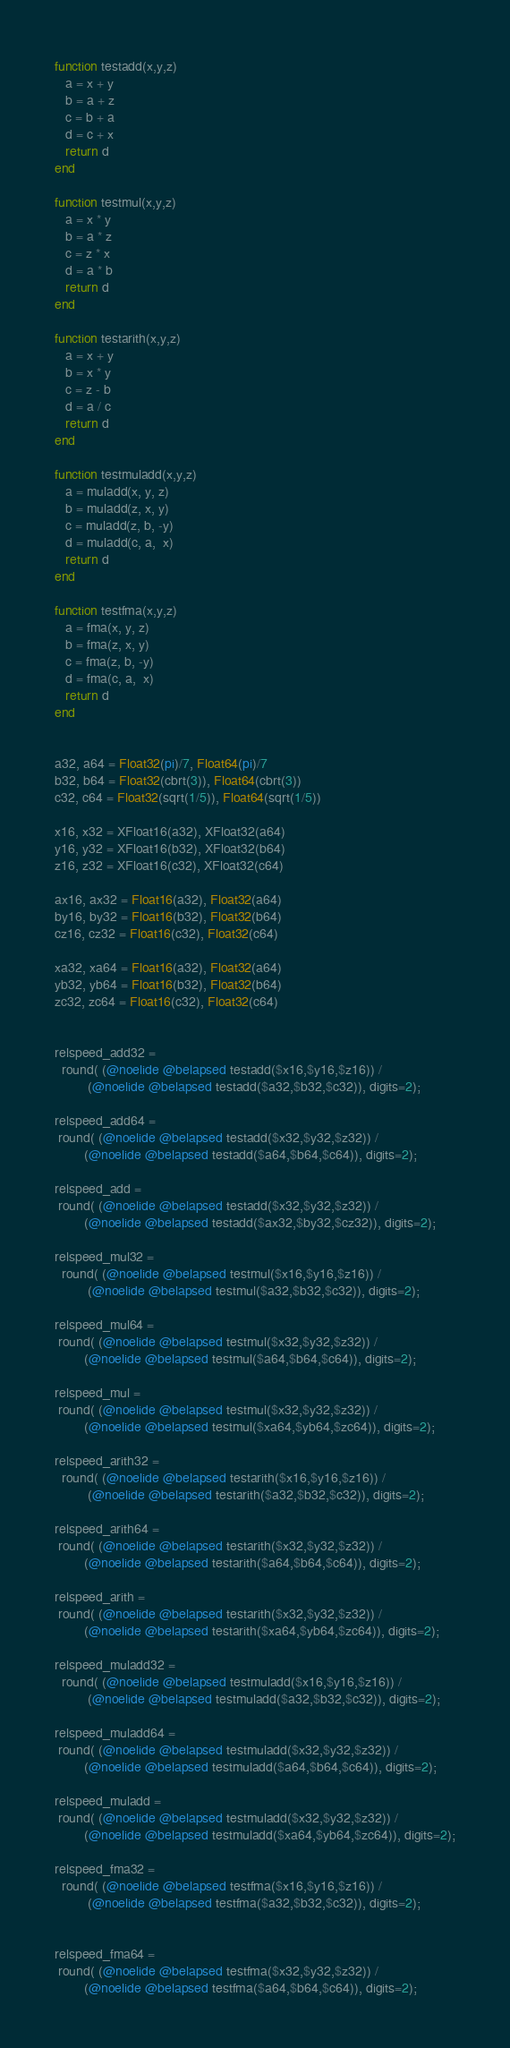<code> <loc_0><loc_0><loc_500><loc_500><_Julia_>
function testadd(x,y,z)
   a = x + y
   b = a + z
   c = b + a
   d = c + x
   return d
end

function testmul(x,y,z)
   a = x * y
   b = a * z
   c = z * x
   d = a * b
   return d
end

function testarith(x,y,z)
   a = x + y
   b = x * y
   c = z - b
   d = a / c
   return d
end

function testmuladd(x,y,z)
   a = muladd(x, y, z)
   b = muladd(z, x, y)
   c = muladd(z, b, -y)
   d = muladd(c, a,  x)
   return d
end

function testfma(x,y,z)
   a = fma(x, y, z)
   b = fma(z, x, y)
   c = fma(z, b, -y)
   d = fma(c, a,  x)
   return d
end


a32, a64 = Float32(pi)/7, Float64(pi)/7
b32, b64 = Float32(cbrt(3)), Float64(cbrt(3))
c32, c64 = Float32(sqrt(1/5)), Float64(sqrt(1/5))

x16, x32 = XFloat16(a32), XFloat32(a64)
y16, y32 = XFloat16(b32), XFloat32(b64)
z16, z32 = XFloat16(c32), XFloat32(c64)

ax16, ax32 = Float16(a32), Float32(a64)
by16, by32 = Float16(b32), Float32(b64)
cz16, cz32 = Float16(c32), Float32(c64)

xa32, xa64 = Float16(a32), Float32(a64)
yb32, yb64 = Float16(b32), Float32(b64)
zc32, zc64 = Float16(c32), Float32(c64)


relspeed_add32 =
  round( (@noelide @belapsed testadd($x16,$y16,$z16)) /
         (@noelide @belapsed testadd($a32,$b32,$c32)), digits=2);

relspeed_add64 =
 round( (@noelide @belapsed testadd($x32,$y32,$z32)) /
        (@noelide @belapsed testadd($a64,$b64,$c64)), digits=2);

relspeed_add =
 round( (@noelide @belapsed testadd($x32,$y32,$z32)) /
        (@noelide @belapsed testadd($ax32,$by32,$cz32)), digits=2);

relspeed_mul32 =
  round( (@noelide @belapsed testmul($x16,$y16,$z16)) /
         (@noelide @belapsed testmul($a32,$b32,$c32)), digits=2);

relspeed_mul64 =
 round( (@noelide @belapsed testmul($x32,$y32,$z32)) /
        (@noelide @belapsed testmul($a64,$b64,$c64)), digits=2);

relspeed_mul =
 round( (@noelide @belapsed testmul($x32,$y32,$z32)) /
        (@noelide @belapsed testmul($xa64,$yb64,$zc64)), digits=2);

relspeed_arith32 =
  round( (@noelide @belapsed testarith($x16,$y16,$z16)) /
         (@noelide @belapsed testarith($a32,$b32,$c32)), digits=2);

relspeed_arith64 =
 round( (@noelide @belapsed testarith($x32,$y32,$z32)) /
        (@noelide @belapsed testarith($a64,$b64,$c64)), digits=2);

relspeed_arith =
 round( (@noelide @belapsed testarith($x32,$y32,$z32)) /
        (@noelide @belapsed testarith($xa64,$yb64,$zc64)), digits=2);

relspeed_muladd32 =
  round( (@noelide @belapsed testmuladd($x16,$y16,$z16)) /
         (@noelide @belapsed testmuladd($a32,$b32,$c32)), digits=2);

relspeed_muladd64 =
 round( (@noelide @belapsed testmuladd($x32,$y32,$z32)) /
        (@noelide @belapsed testmuladd($a64,$b64,$c64)), digits=2);

relspeed_muladd =
 round( (@noelide @belapsed testmuladd($x32,$y32,$z32)) /
        (@noelide @belapsed testmuladd($xa64,$yb64,$zc64)), digits=2);

relspeed_fma32 =
  round( (@noelide @belapsed testfma($x16,$y16,$z16)) /
         (@noelide @belapsed testfma($a32,$b32,$c32)), digits=2);


relspeed_fma64 =
 round( (@noelide @belapsed testfma($x32,$y32,$z32)) /
        (@noelide @belapsed testfma($a64,$b64,$c64)), digits=2);
</code> 